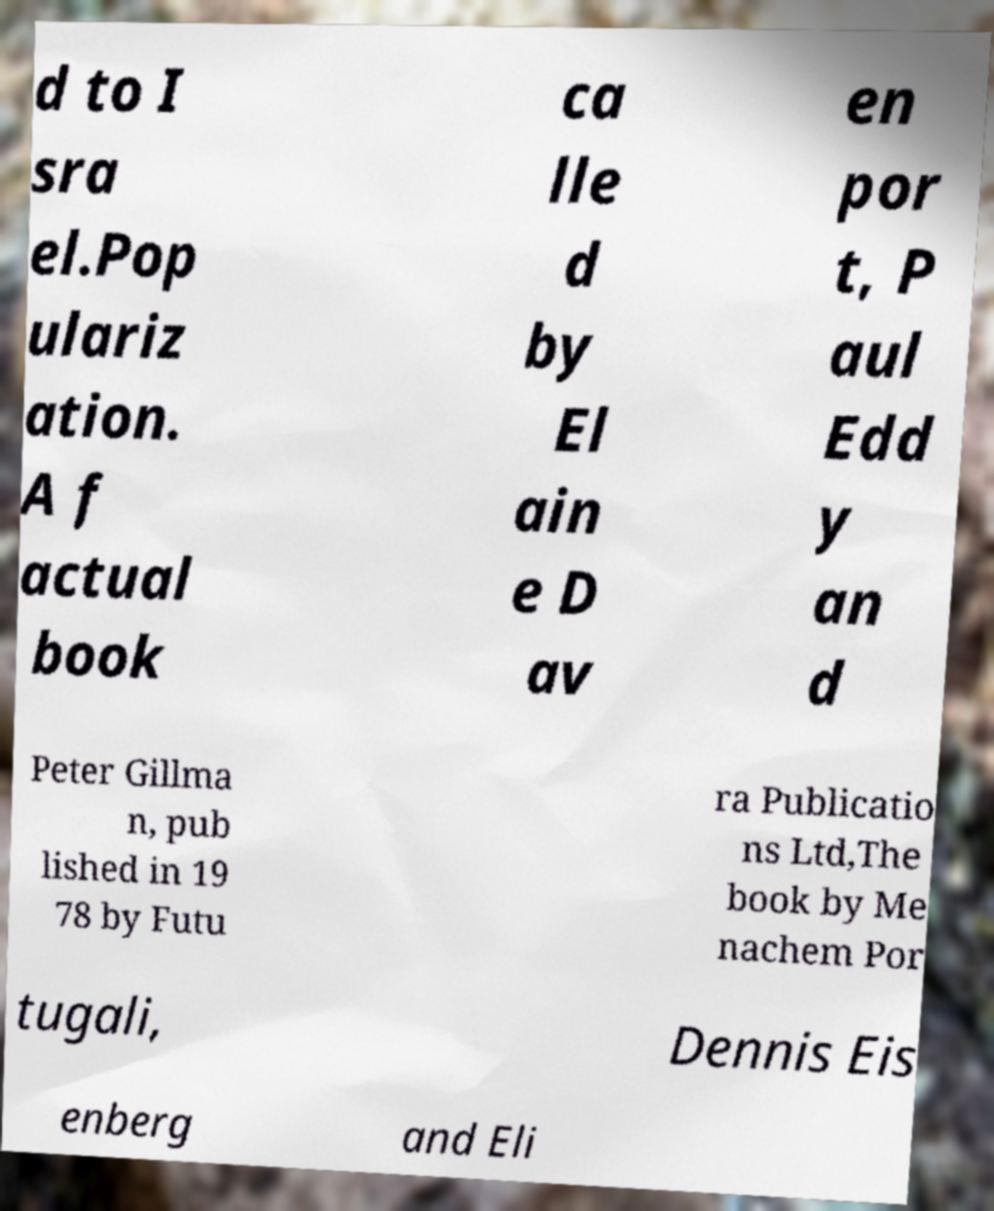Could you assist in decoding the text presented in this image and type it out clearly? d to I sra el.Pop ulariz ation. A f actual book ca lle d by El ain e D av en por t, P aul Edd y an d Peter Gillma n, pub lished in 19 78 by Futu ra Publicatio ns Ltd,The book by Me nachem Por tugali, Dennis Eis enberg and Eli 